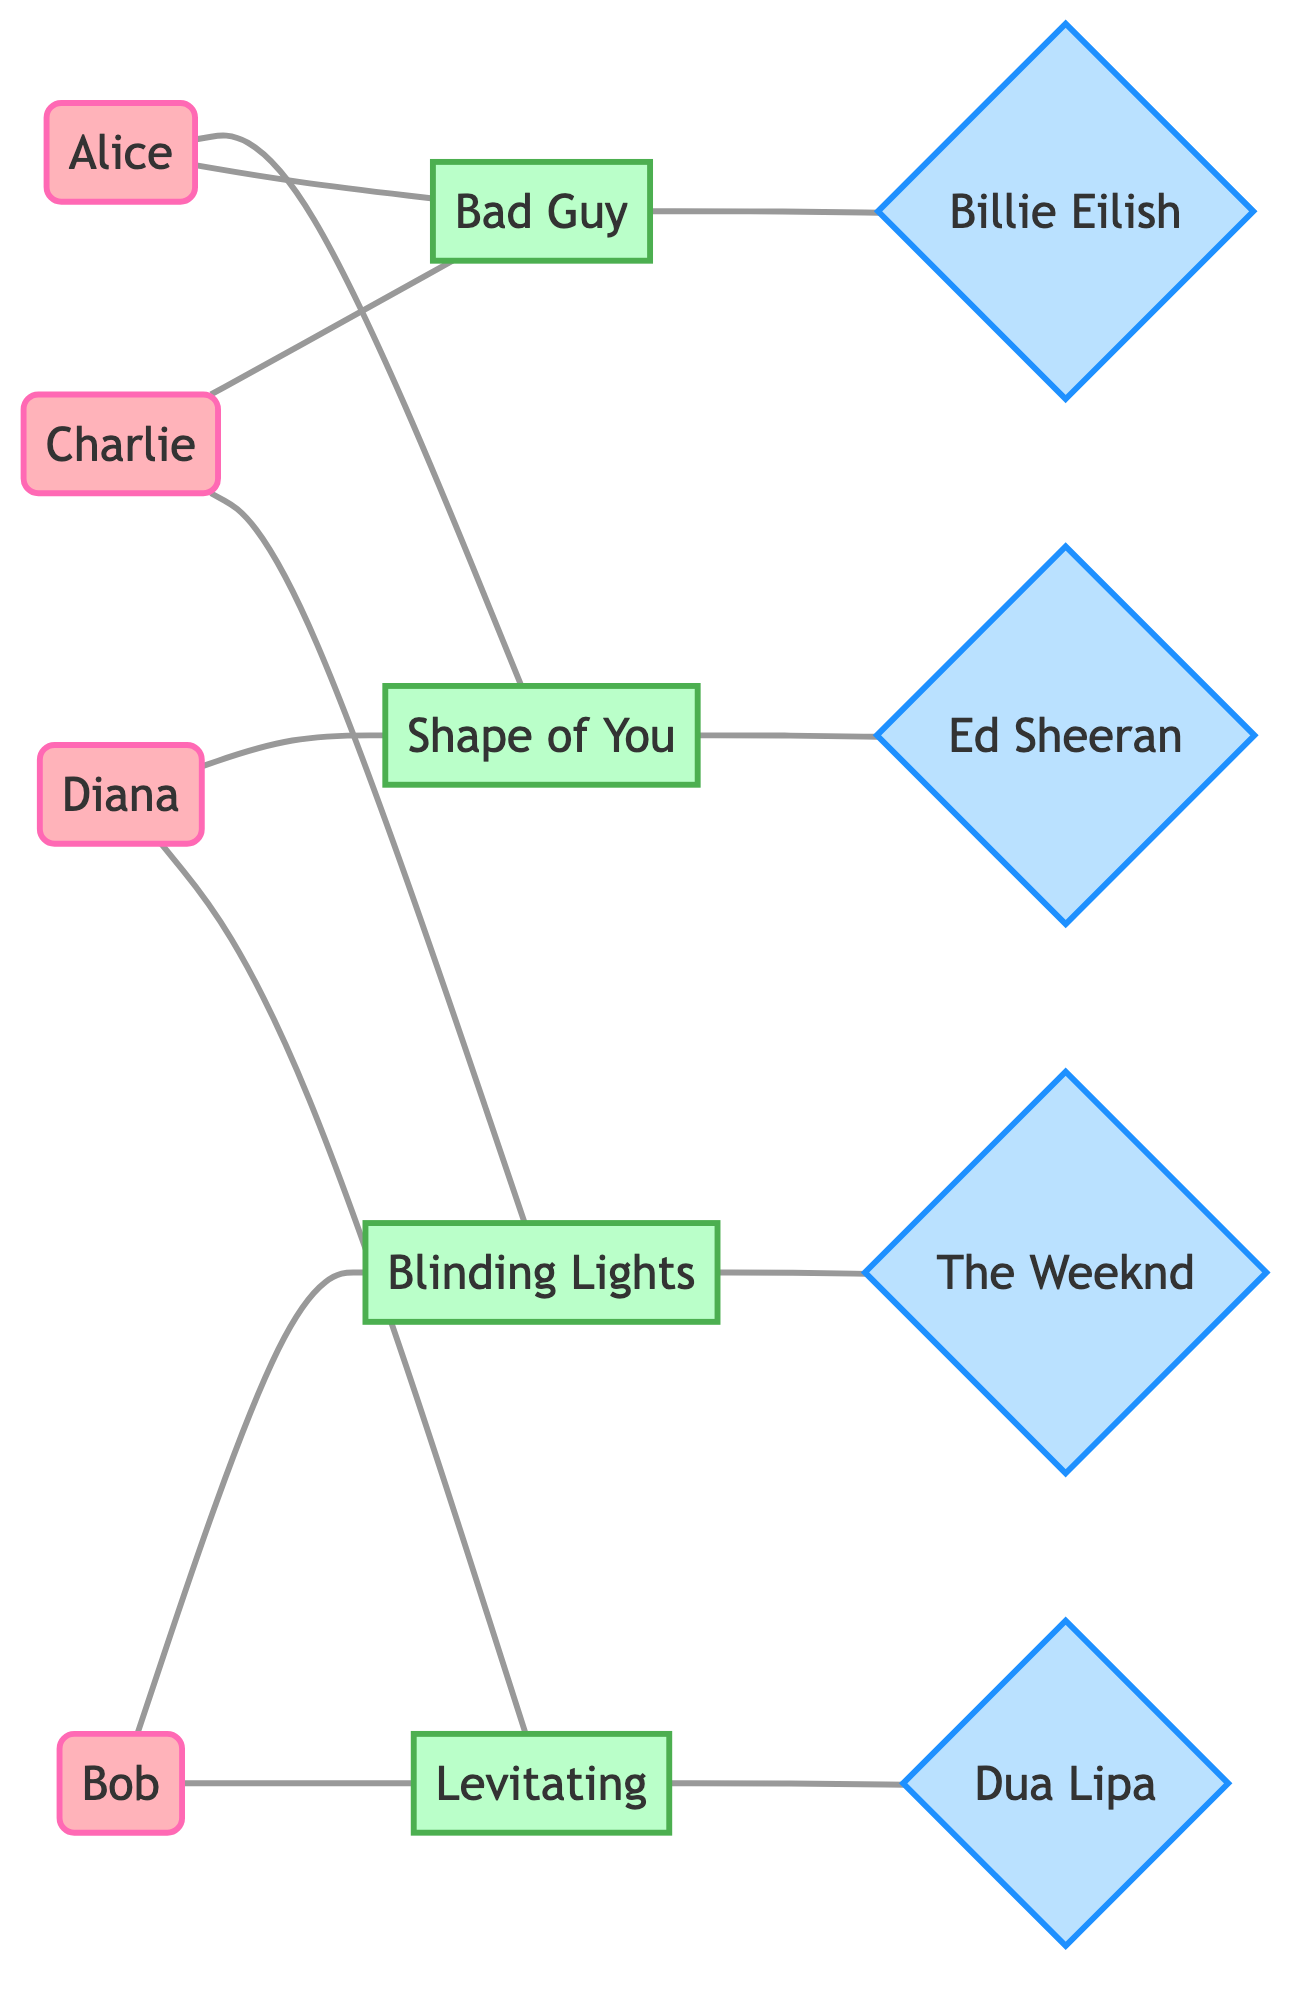What's the total number of students in the diagram? The diagram lists four students: Alice, Bob, Charlie, and Diana. Counting each one gives a total of four.
Answer: 4 Which singer is associated with the song "Shape of You"? The diagram shows a connection from the song "Shape of You" to the singer Ed Sheeran, indicating he performs this song.
Answer: Ed Sheeran How many favorite songs does Bob have? Bob has two favorite songs listed: "Blinding Lights" and "Levitating." This can be counted directly from his connections in the diagram.
Answer: 2 Which student shares the most favorite songs with Charlie? Both Charlie and Bob share two favorite songs: "Blinding Lights" and "Bad Guy," while Alice and Diana share no songs with Charlie. Therefore, Charlie has the strongest connection with Bob.
Answer: Bob Which singer has the highest number of connections to favorite songs in the diagram? Analyzing the connections, Billie Eilish is connected to two songs ("Bad Guy"), while Ed Sheeran and Dua Lipa each are connected to two different songs. Each singer listed has the same number of connections; however, they are all shared, so no single singer stands out as having more connections than the others.
Answer: None (or equal) Which song is liked by both Alice and Diana? The diagram shows that both Alice and Diana have a connection to the song "Shape of You." This indicates that both students have this song as a favorite.
Answer: Shape of You How many unique songs are depicted in the diagram? The diagram lists four unique songs: "Shape of You," "Bad Guy," "Blinding Lights," and "Levitating." Counting these distinct songs gives a total of four.
Answer: 4 Which of the following songs is not liked by any student: "Bad Guy", "Shape of You", "Stay"? Assessing the connections, "Bad Guy" and "Shape of You" are both favored by students, while "Stay" is not mentioned in the diagram, indicating no student has it as a favorite.
Answer: Stay Which two singers share a song with both a student and another singer? The song "Levitating" is associated with both the singer Dua Lipa and the student Bob, as well as the student Diana. This shows a shared preference across both students and the singer.
Answer: Dua Lipa 